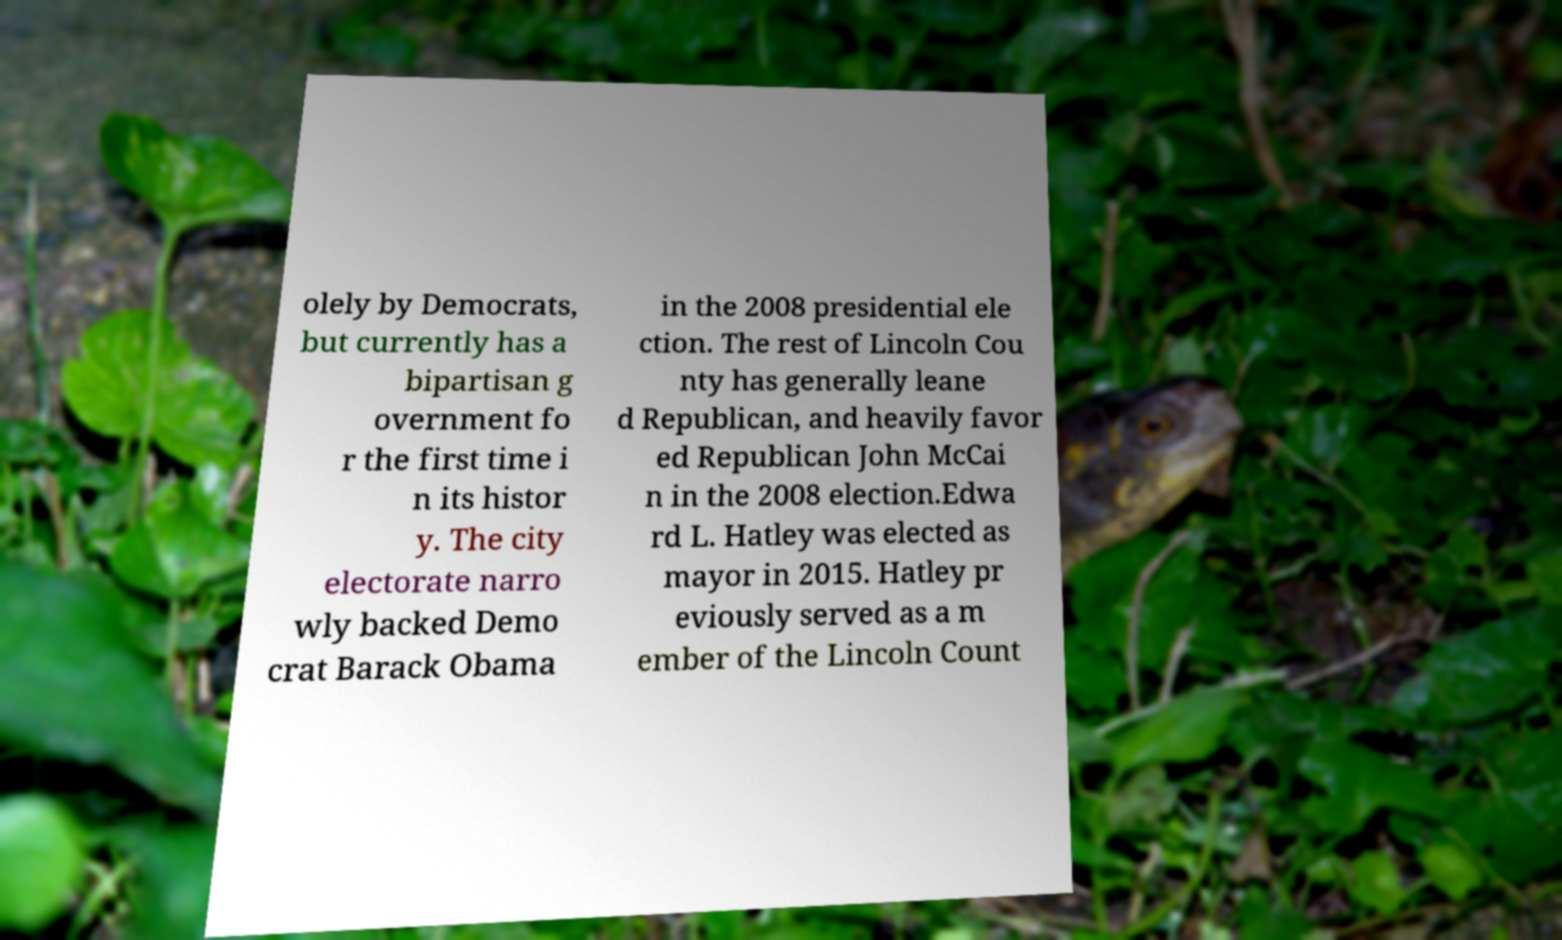Could you extract and type out the text from this image? olely by Democrats, but currently has a bipartisan g overnment fo r the first time i n its histor y. The city electorate narro wly backed Demo crat Barack Obama in the 2008 presidential ele ction. The rest of Lincoln Cou nty has generally leane d Republican, and heavily favor ed Republican John McCai n in the 2008 election.Edwa rd L. Hatley was elected as mayor in 2015. Hatley pr eviously served as a m ember of the Lincoln Count 